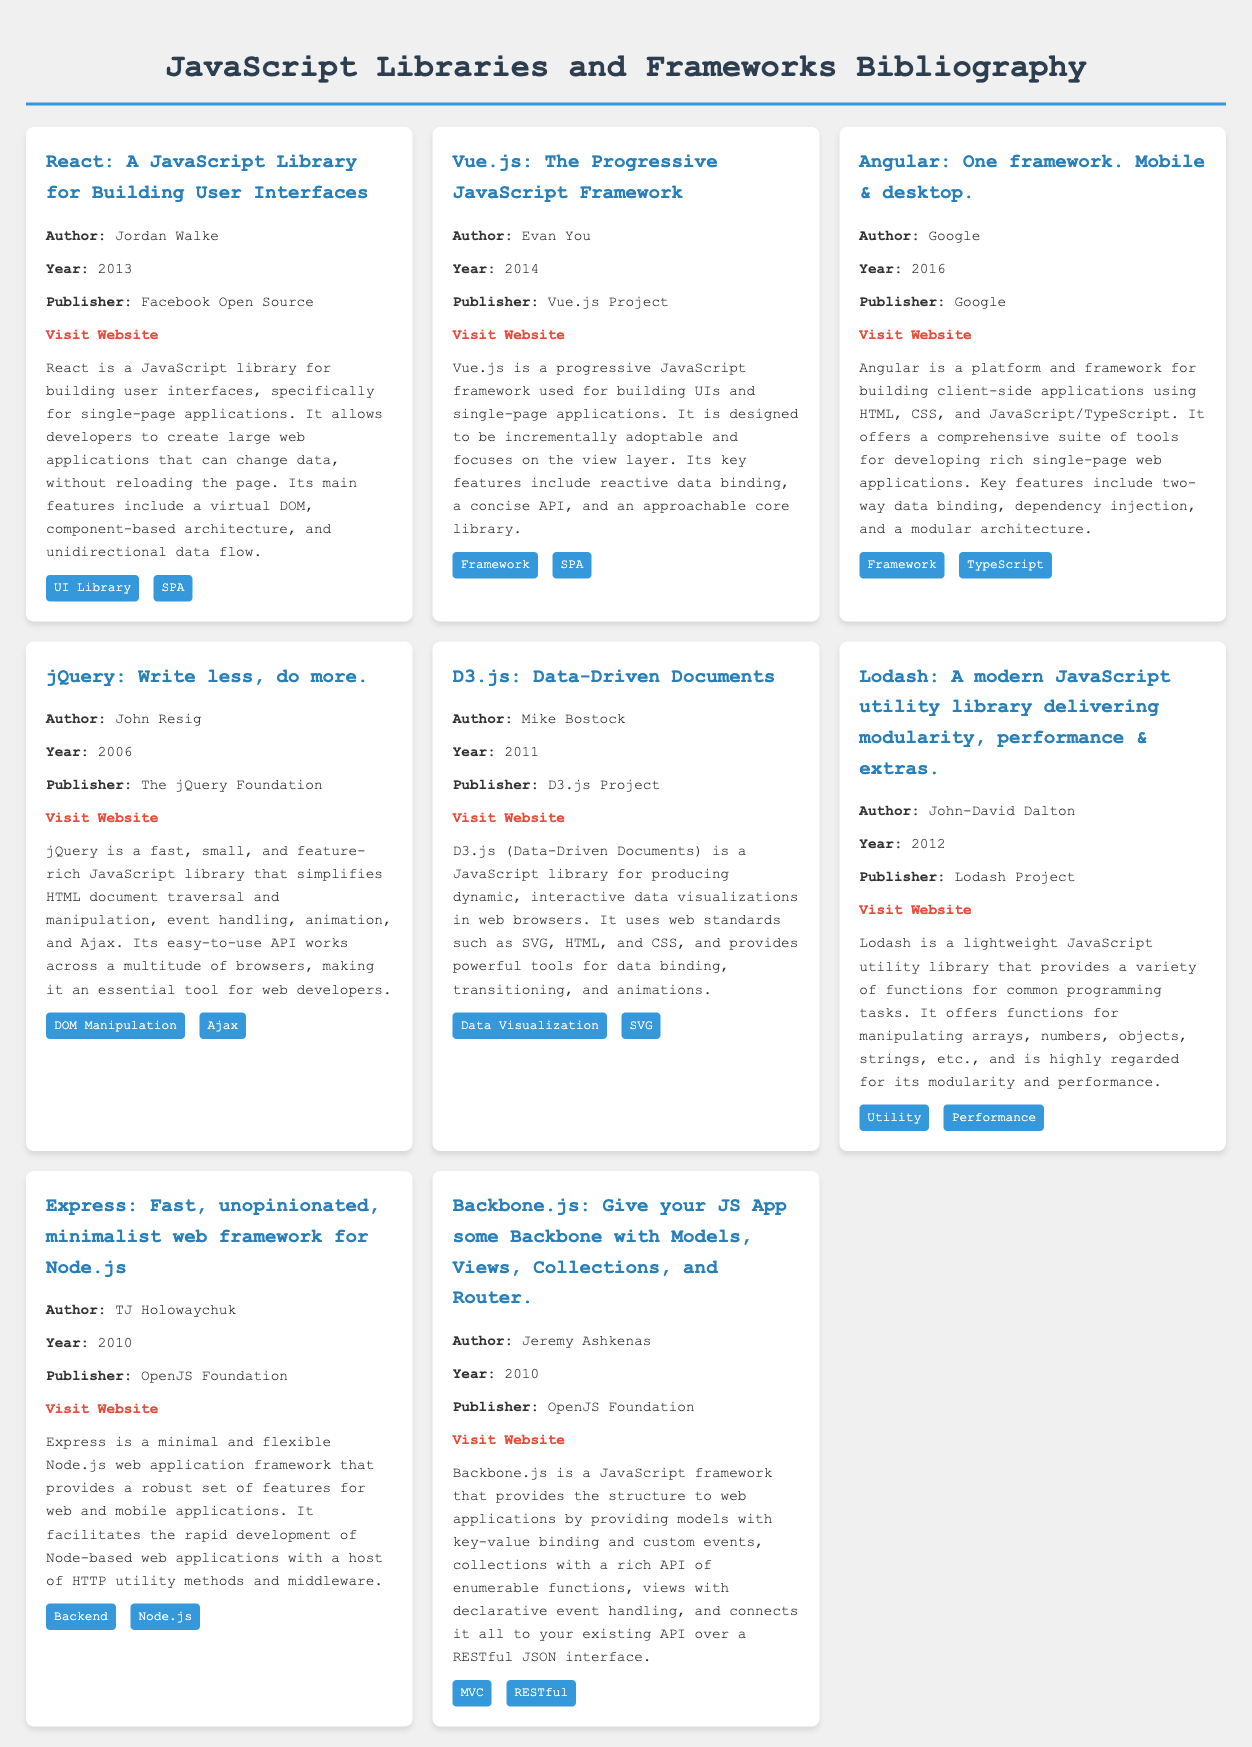What is the title of the first entry? The title of the first entry is stated in the document under the first entry section.
Answer: A JavaScript Library for Building User Interfaces Who is the author of Vue.js? The author of Vue.js is mentioned in the entry about Vue.js.
Answer: Evan You What year was Angular published? The year of publication for Angular is clearly listed in the corresponding entry.
Answer: 2016 Which library/framework is described as "Write less, do more"? The phrase describing jQuery is found in its entry, making it identifiable.
Answer: jQuery How many entries mention the term "SPA"? The term "SPA" appears in the tags of two entries, which can be counted.
Answer: 2 What is the main feature of D3.js mentioned in the description? The main feature of D3.js is included within its entry details about data visualizations.
Answer: Data visualizations Which framework is associated with TypeScript? The entry for Angular includes TypeScript among its notable features.
Answer: Angular Who published Lodash? The publisher of Lodash is articulated in its entry section.
Answer: Lodash Project What type of library is Express classified as? The classification of Express is identified within its description.
Answer: Backend 